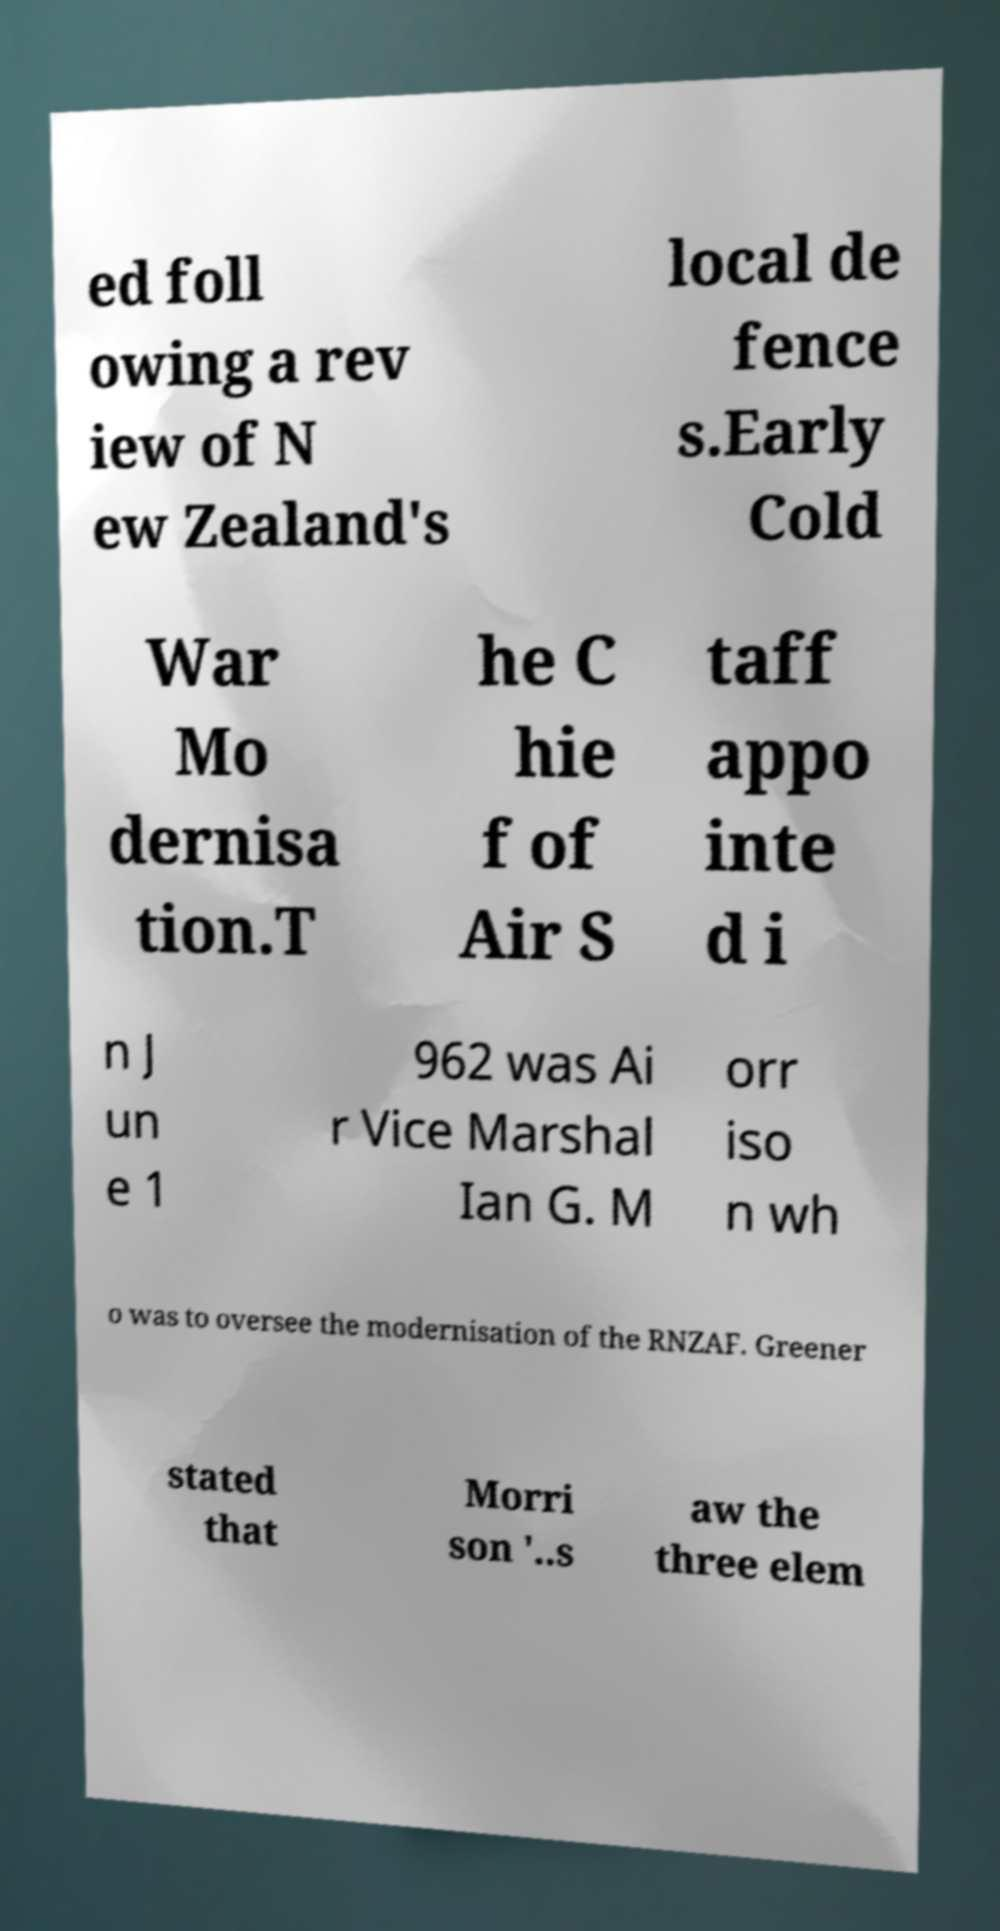There's text embedded in this image that I need extracted. Can you transcribe it verbatim? ed foll owing a rev iew of N ew Zealand's local de fence s.Early Cold War Mo dernisa tion.T he C hie f of Air S taff appo inte d i n J un e 1 962 was Ai r Vice Marshal Ian G. M orr iso n wh o was to oversee the modernisation of the RNZAF. Greener stated that Morri son '..s aw the three elem 